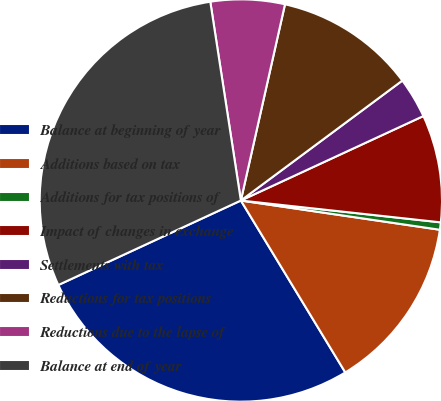Convert chart. <chart><loc_0><loc_0><loc_500><loc_500><pie_chart><fcel>Balance at beginning of year<fcel>Additions based on tax<fcel>Additions for tax positions of<fcel>Impact of changes in exchange<fcel>Settlements with tax<fcel>Reductions for tax positions<fcel>Reductions due to the lapse of<fcel>Balance at end of year<nl><fcel>26.79%<fcel>13.99%<fcel>0.59%<fcel>8.63%<fcel>3.27%<fcel>11.31%<fcel>5.95%<fcel>29.47%<nl></chart> 